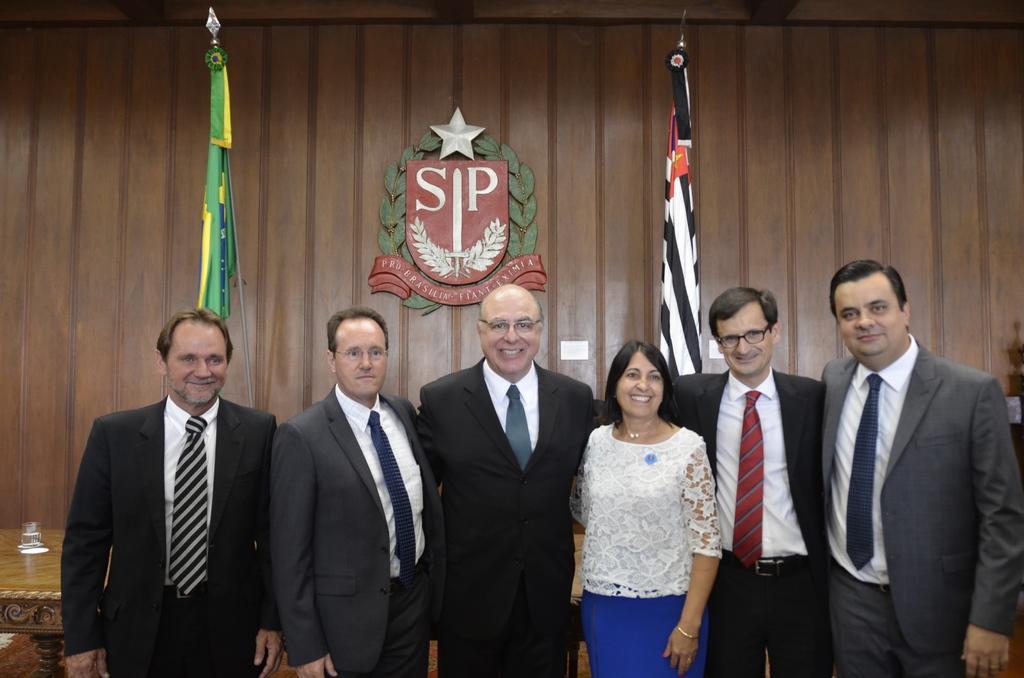How would you summarize this image in a sentence or two? In this image I can see 6 people standing in a room. A person in the center is wearing a white shirt and blue pant. Other people are wearing suit. There are flags behind them and a glass is present on a table. There is a wooden background. 